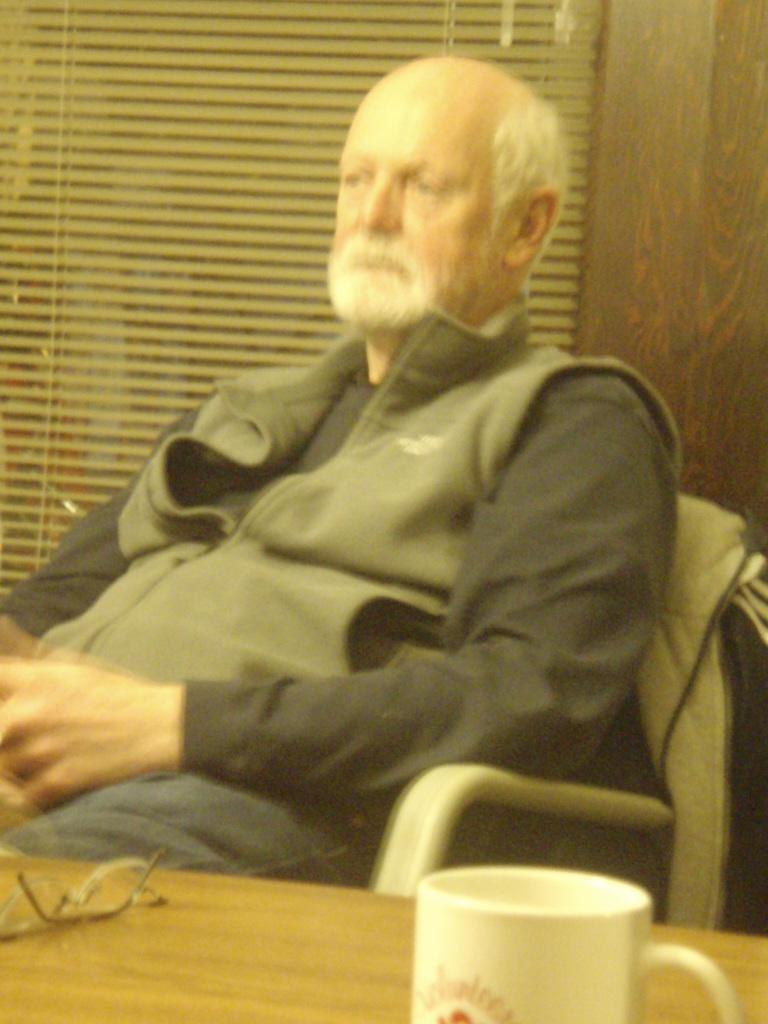In one or two sentences, can you explain what this image depicts? In this picture we can see a man sitting on a chair. He wore a jacket which is gray in colour. On the background we can see a grilled curtain. On the table we can see there are spectacles and a white colour coffee mug. 